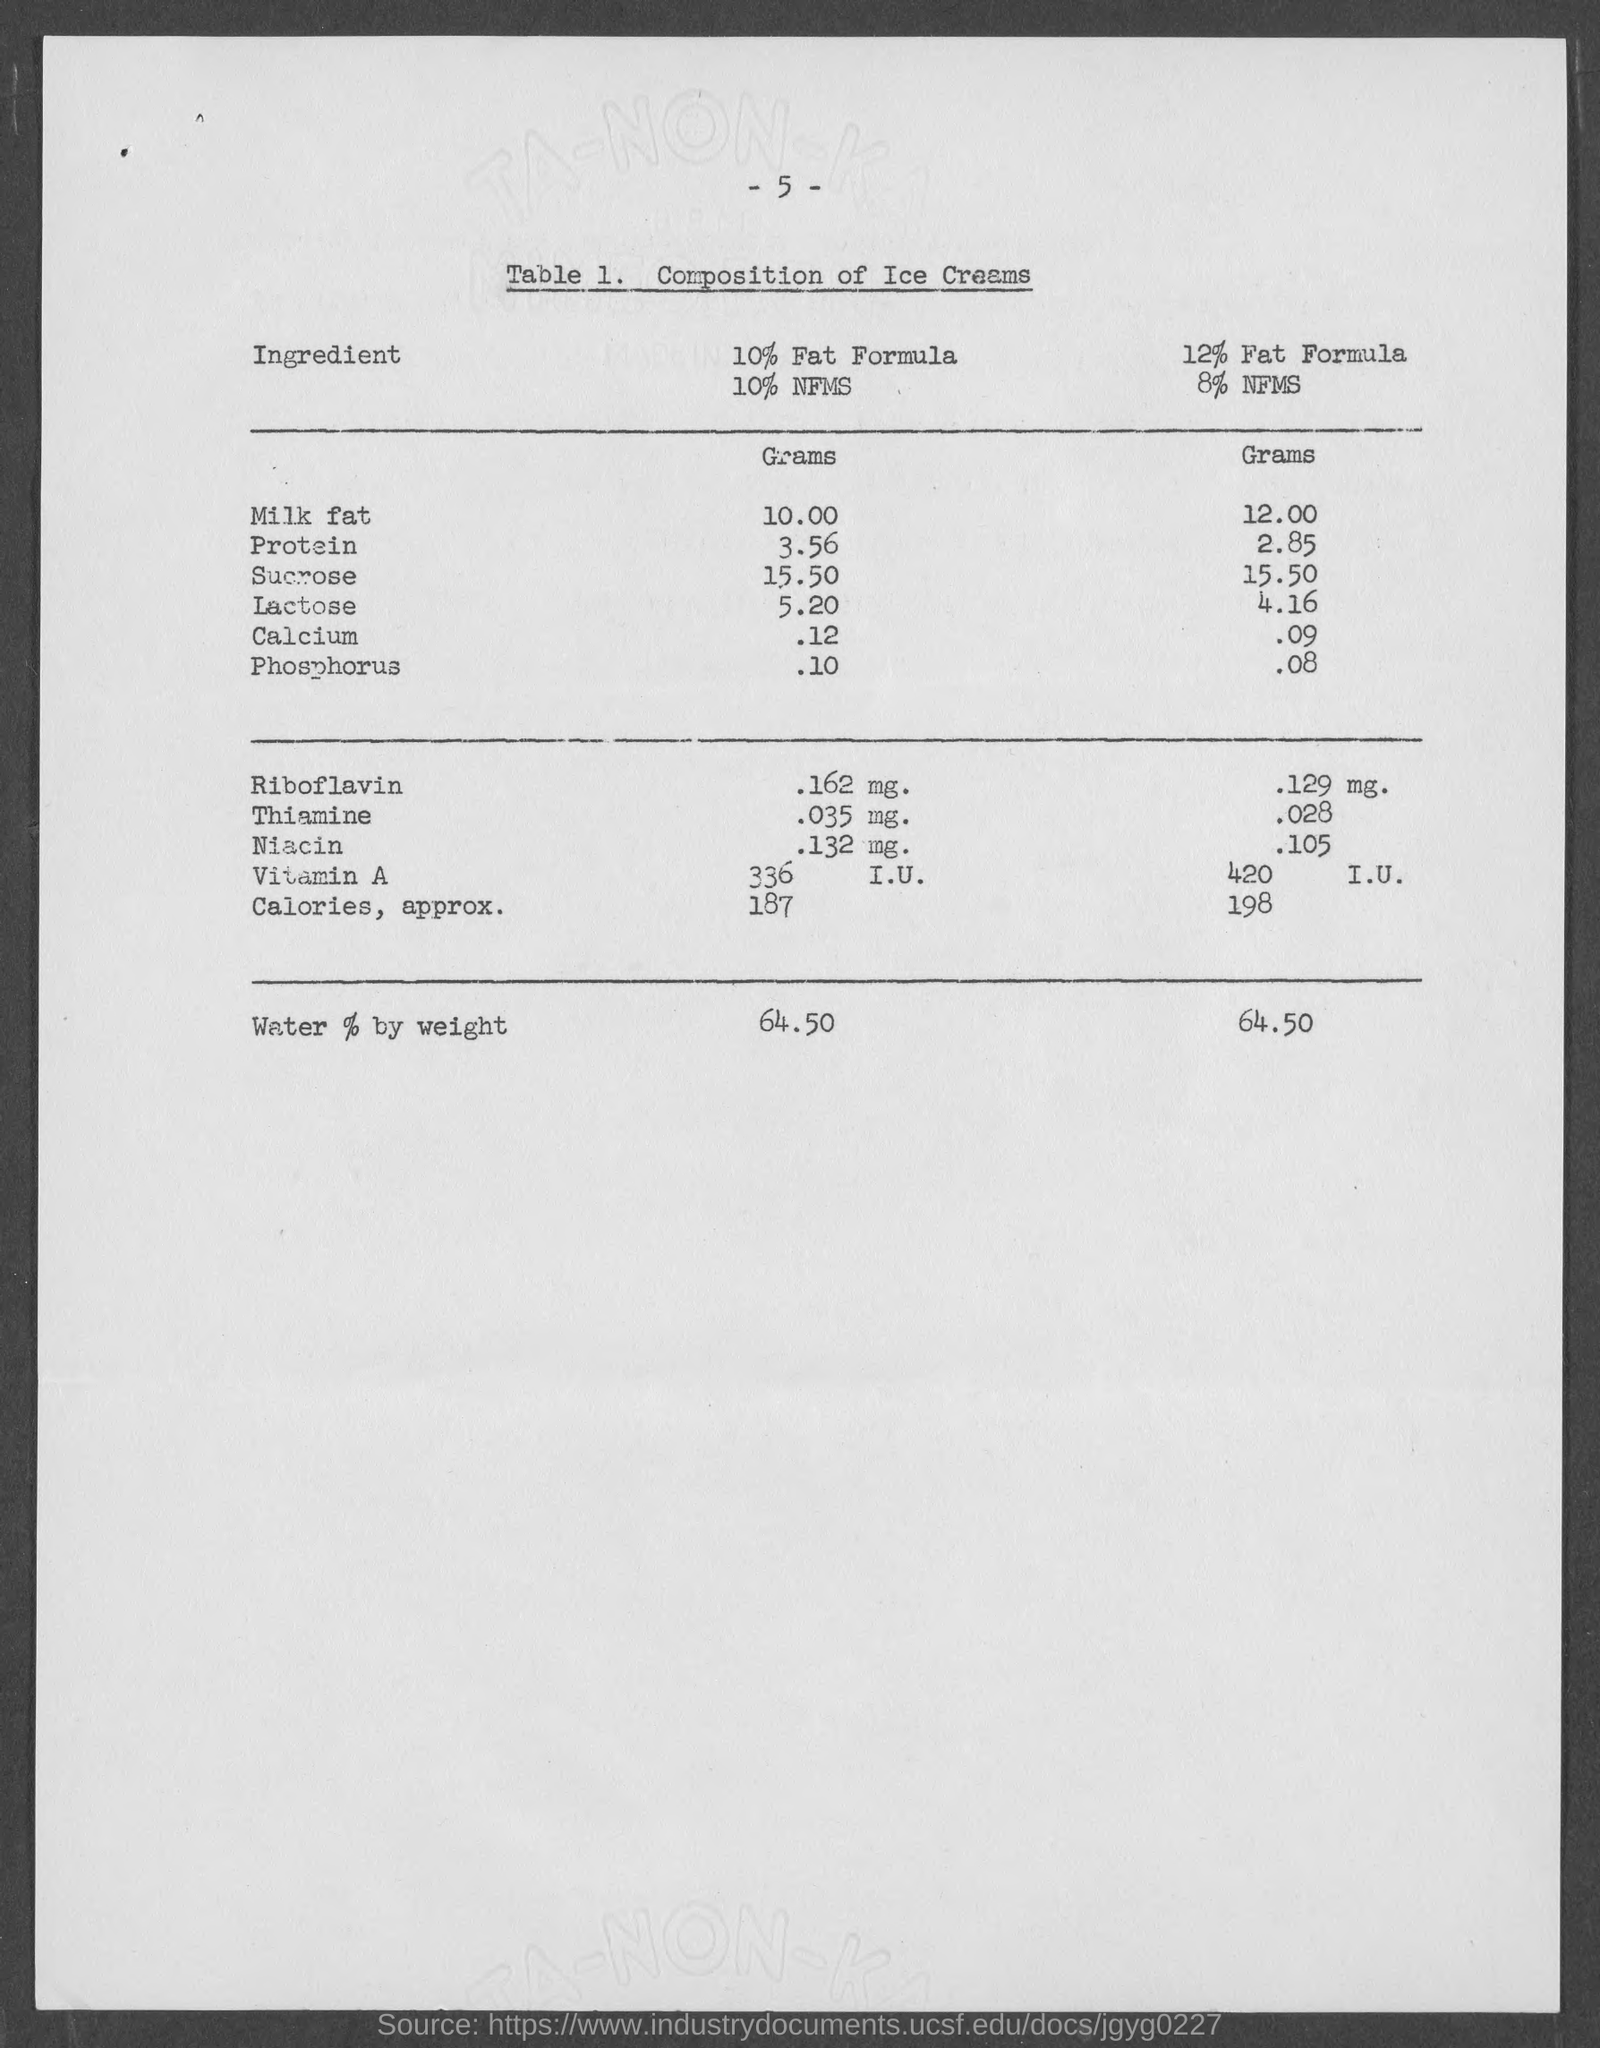What is the number at top of the page ?
Ensure brevity in your answer.  5. 